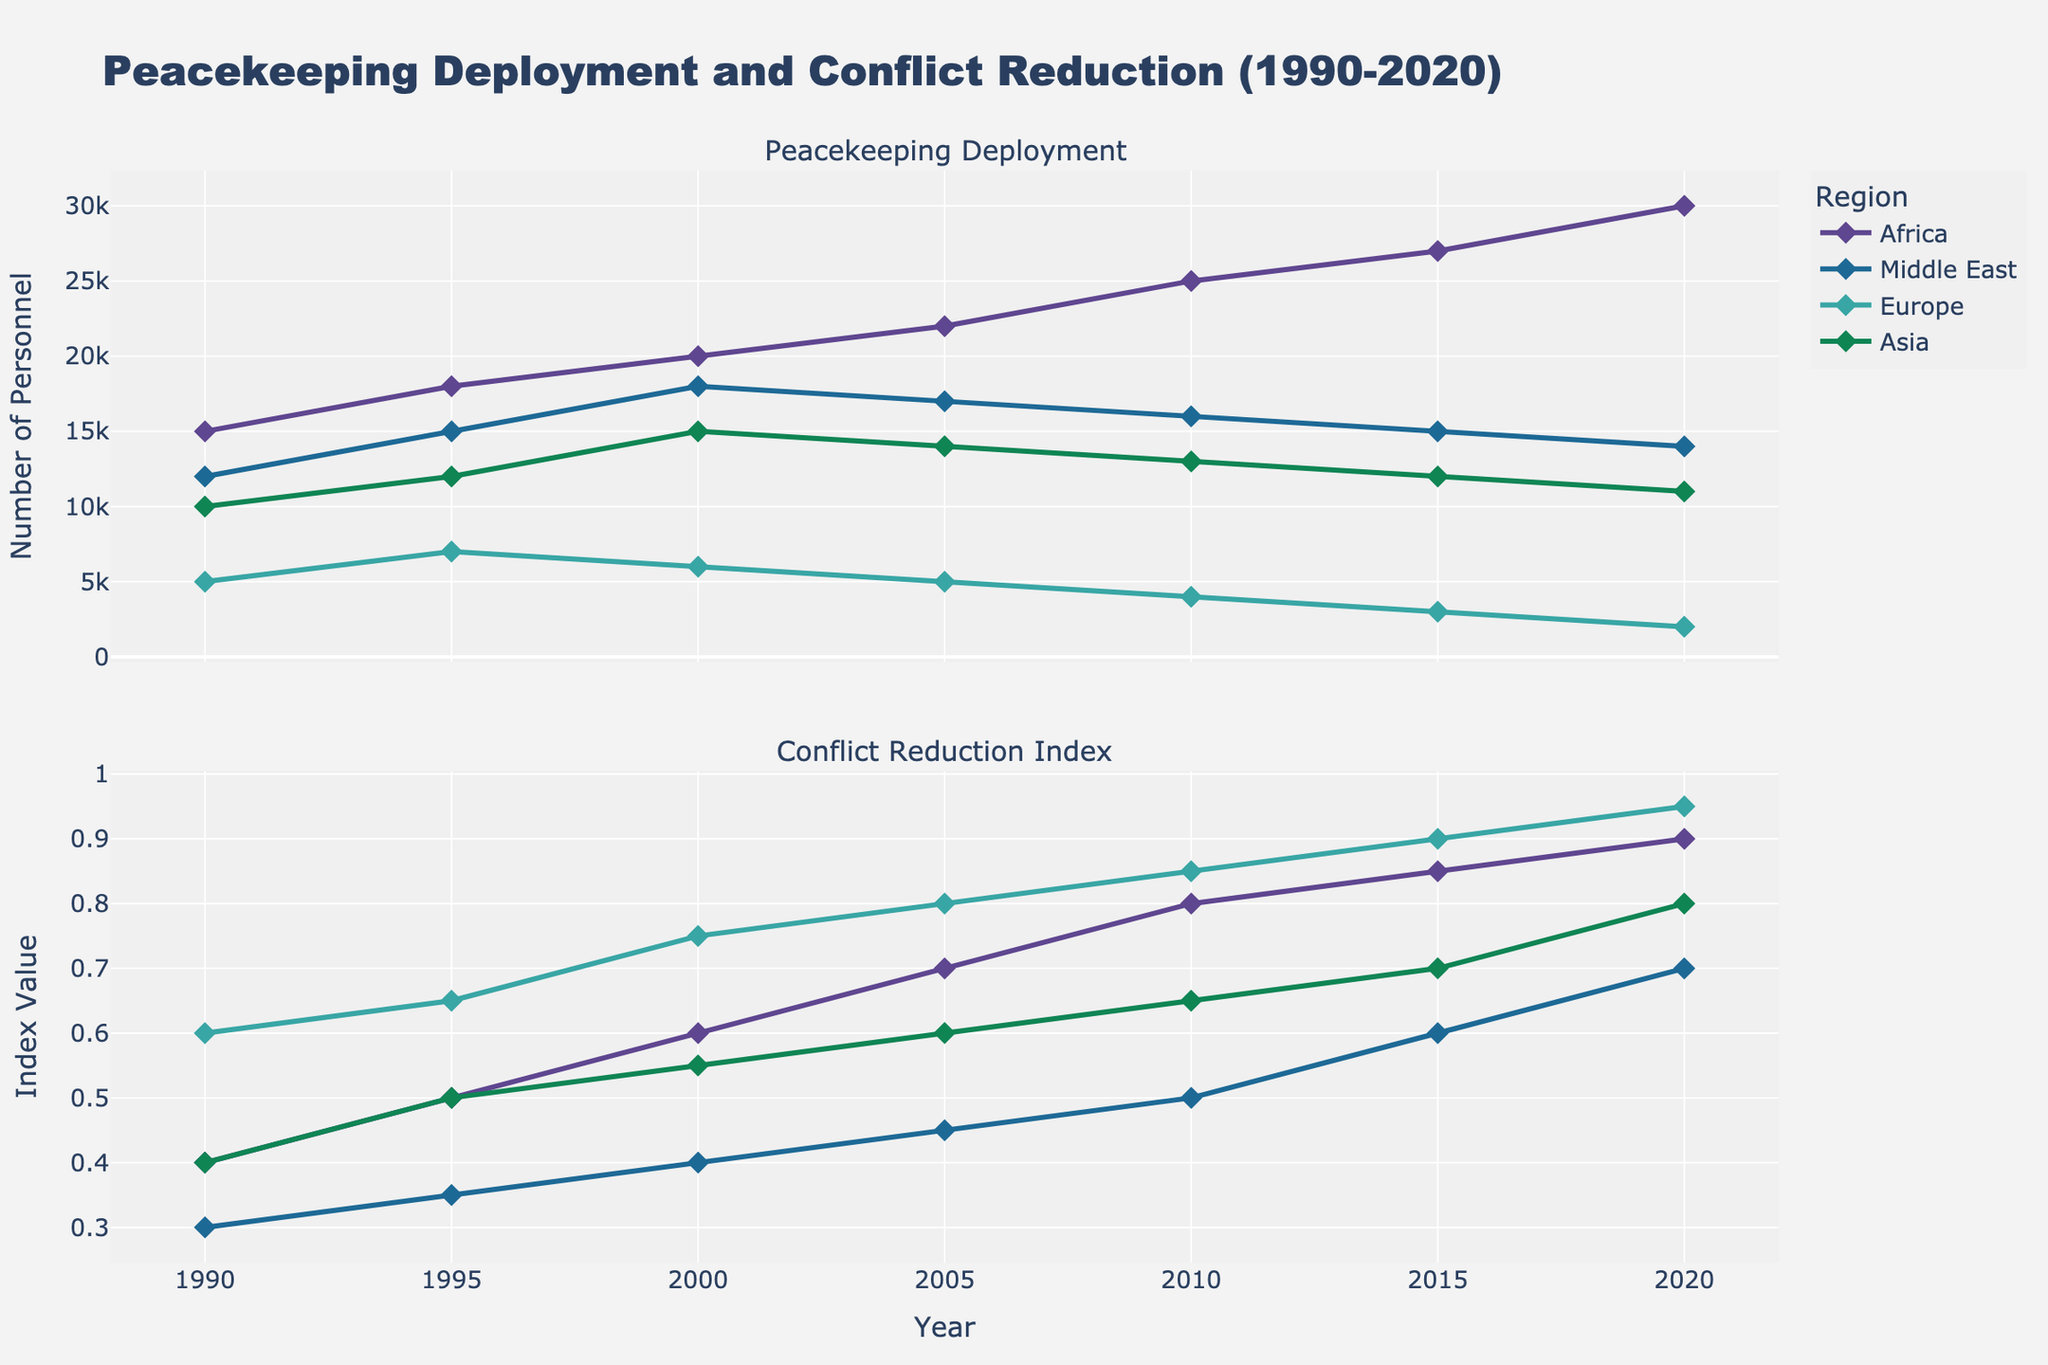How many regions are represented in the figure? The figure shows unique entries for different regions depicted with various colors. You can count the distinct markers or labels that represent each region.
Answer: 4 What is the peak Peacekeeping Deployment for the Middle East and in which year did it occur? Look for the highest point in the Peacekeeping Deployment line for the Middle East. The year corresponding to this peak value is the one you are looking for.
Answer: 2000, 18000 How does the Conflict Reduction Index for Europe change over the years? Observe the Conflict Reduction Index line for Europe from 1990 to 2020. Trace the upward or downward trend to determine the overall change.
Answer: It consistently increases Which region had the highest Conflict Reduction Index in 2020? Compare the values of the Conflict Reduction Index for all regions in 2020. The highest index value is the one we are looking for.
Answer: Europe What is the difference in Peacekeeping Deployment between Africa and Asia in 2010? Find the Peacekeeping Deployment values for both Africa and Asia in 2010 and subtract the smaller number from the larger one.
Answer: 12000 Which region experienced the largest increase in the Conflict Reduction Index from 1990 to 2020? Calculate the difference in the Conflict Reduction Index between 1990 and 2020 for each region. Compare these differences to find the region with the largest increase.
Answer: Middle East How did the Peacekeeping Deployment in Africa change between 1990 and 2000? Identify the Peacekeeping Deployment values for Africa in 1990 and 2000, and observe the trend to describe the change.
Answer: It increased from 15000 to 20000 Is there a region where the Peacekeeping Deployment decreased over the span of years? If so, which one and in what period? Observe the individual regional lines for any downward trends over the years. Note the region and corresponding years where a decrease is observed.
Answer: Middle East, 2000 to 2020 What was the trend in the Conflict Reduction Index for Asia between 1995 and 2015? Look at the Conflict Reduction Index for Asia from 1995 to 2015 and describe the overall trend or any noticeable changes.
Answer: It increased from 0.5 to 0.7 Which region had the least fluctuation in Peacekeeping Deployment from 1990 to 2020? By comparing the highs and lows in the Peacekeeping Deployment lines for each region, determine the region with the smallest range in values.
Answer: Europe 